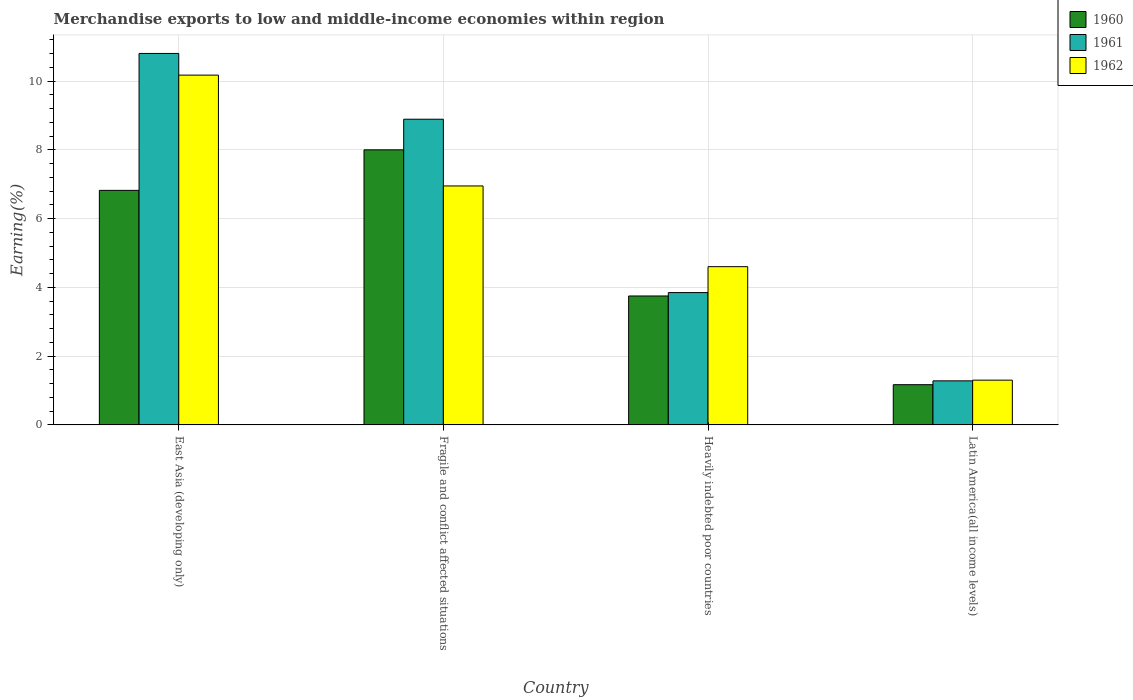How many different coloured bars are there?
Give a very brief answer. 3. How many groups of bars are there?
Provide a short and direct response. 4. How many bars are there on the 4th tick from the left?
Keep it short and to the point. 3. How many bars are there on the 2nd tick from the right?
Ensure brevity in your answer.  3. What is the label of the 4th group of bars from the left?
Offer a terse response. Latin America(all income levels). What is the percentage of amount earned from merchandise exports in 1962 in Fragile and conflict affected situations?
Provide a succinct answer. 6.95. Across all countries, what is the maximum percentage of amount earned from merchandise exports in 1962?
Offer a terse response. 10.17. Across all countries, what is the minimum percentage of amount earned from merchandise exports in 1961?
Provide a succinct answer. 1.28. In which country was the percentage of amount earned from merchandise exports in 1960 maximum?
Give a very brief answer. Fragile and conflict affected situations. In which country was the percentage of amount earned from merchandise exports in 1960 minimum?
Offer a very short reply. Latin America(all income levels). What is the total percentage of amount earned from merchandise exports in 1960 in the graph?
Give a very brief answer. 19.74. What is the difference between the percentage of amount earned from merchandise exports in 1961 in Fragile and conflict affected situations and that in Latin America(all income levels)?
Your answer should be very brief. 7.61. What is the difference between the percentage of amount earned from merchandise exports in 1961 in Latin America(all income levels) and the percentage of amount earned from merchandise exports in 1960 in East Asia (developing only)?
Provide a succinct answer. -5.54. What is the average percentage of amount earned from merchandise exports in 1962 per country?
Offer a very short reply. 5.76. What is the difference between the percentage of amount earned from merchandise exports of/in 1962 and percentage of amount earned from merchandise exports of/in 1961 in Heavily indebted poor countries?
Provide a short and direct response. 0.75. In how many countries, is the percentage of amount earned from merchandise exports in 1962 greater than 4.8 %?
Provide a short and direct response. 2. What is the ratio of the percentage of amount earned from merchandise exports in 1960 in Heavily indebted poor countries to that in Latin America(all income levels)?
Make the answer very short. 3.2. Is the percentage of amount earned from merchandise exports in 1962 in East Asia (developing only) less than that in Fragile and conflict affected situations?
Ensure brevity in your answer.  No. What is the difference between the highest and the second highest percentage of amount earned from merchandise exports in 1960?
Ensure brevity in your answer.  4.25. What is the difference between the highest and the lowest percentage of amount earned from merchandise exports in 1960?
Ensure brevity in your answer.  6.83. Is the sum of the percentage of amount earned from merchandise exports in 1962 in East Asia (developing only) and Fragile and conflict affected situations greater than the maximum percentage of amount earned from merchandise exports in 1961 across all countries?
Your answer should be compact. Yes. What does the 2nd bar from the left in East Asia (developing only) represents?
Your answer should be very brief. 1961. What does the 2nd bar from the right in Latin America(all income levels) represents?
Your response must be concise. 1961. Is it the case that in every country, the sum of the percentage of amount earned from merchandise exports in 1962 and percentage of amount earned from merchandise exports in 1960 is greater than the percentage of amount earned from merchandise exports in 1961?
Your response must be concise. Yes. Are all the bars in the graph horizontal?
Your response must be concise. No. How many countries are there in the graph?
Provide a succinct answer. 4. Are the values on the major ticks of Y-axis written in scientific E-notation?
Provide a succinct answer. No. Where does the legend appear in the graph?
Offer a terse response. Top right. How are the legend labels stacked?
Offer a very short reply. Vertical. What is the title of the graph?
Your response must be concise. Merchandise exports to low and middle-income economies within region. Does "2014" appear as one of the legend labels in the graph?
Your answer should be compact. No. What is the label or title of the X-axis?
Your answer should be compact. Country. What is the label or title of the Y-axis?
Ensure brevity in your answer.  Earning(%). What is the Earning(%) of 1960 in East Asia (developing only)?
Provide a succinct answer. 6.82. What is the Earning(%) in 1961 in East Asia (developing only)?
Your response must be concise. 10.8. What is the Earning(%) of 1962 in East Asia (developing only)?
Your answer should be compact. 10.17. What is the Earning(%) of 1960 in Fragile and conflict affected situations?
Keep it short and to the point. 8. What is the Earning(%) in 1961 in Fragile and conflict affected situations?
Your answer should be compact. 8.89. What is the Earning(%) in 1962 in Fragile and conflict affected situations?
Your answer should be compact. 6.95. What is the Earning(%) in 1960 in Heavily indebted poor countries?
Keep it short and to the point. 3.75. What is the Earning(%) of 1961 in Heavily indebted poor countries?
Give a very brief answer. 3.85. What is the Earning(%) of 1962 in Heavily indebted poor countries?
Your answer should be compact. 4.6. What is the Earning(%) in 1960 in Latin America(all income levels)?
Your answer should be compact. 1.17. What is the Earning(%) in 1961 in Latin America(all income levels)?
Provide a short and direct response. 1.28. What is the Earning(%) of 1962 in Latin America(all income levels)?
Ensure brevity in your answer.  1.3. Across all countries, what is the maximum Earning(%) in 1960?
Your response must be concise. 8. Across all countries, what is the maximum Earning(%) of 1961?
Provide a short and direct response. 10.8. Across all countries, what is the maximum Earning(%) of 1962?
Provide a short and direct response. 10.17. Across all countries, what is the minimum Earning(%) in 1960?
Your answer should be compact. 1.17. Across all countries, what is the minimum Earning(%) in 1961?
Provide a succinct answer. 1.28. Across all countries, what is the minimum Earning(%) of 1962?
Provide a short and direct response. 1.3. What is the total Earning(%) of 1960 in the graph?
Your answer should be compact. 19.74. What is the total Earning(%) of 1961 in the graph?
Keep it short and to the point. 24.83. What is the total Earning(%) of 1962 in the graph?
Your answer should be compact. 23.03. What is the difference between the Earning(%) of 1960 in East Asia (developing only) and that in Fragile and conflict affected situations?
Offer a very short reply. -1.18. What is the difference between the Earning(%) in 1961 in East Asia (developing only) and that in Fragile and conflict affected situations?
Make the answer very short. 1.91. What is the difference between the Earning(%) of 1962 in East Asia (developing only) and that in Fragile and conflict affected situations?
Give a very brief answer. 3.22. What is the difference between the Earning(%) in 1960 in East Asia (developing only) and that in Heavily indebted poor countries?
Your answer should be compact. 3.07. What is the difference between the Earning(%) in 1961 in East Asia (developing only) and that in Heavily indebted poor countries?
Ensure brevity in your answer.  6.96. What is the difference between the Earning(%) in 1962 in East Asia (developing only) and that in Heavily indebted poor countries?
Keep it short and to the point. 5.57. What is the difference between the Earning(%) in 1960 in East Asia (developing only) and that in Latin America(all income levels)?
Your answer should be very brief. 5.65. What is the difference between the Earning(%) of 1961 in East Asia (developing only) and that in Latin America(all income levels)?
Your answer should be compact. 9.52. What is the difference between the Earning(%) in 1962 in East Asia (developing only) and that in Latin America(all income levels)?
Offer a terse response. 8.87. What is the difference between the Earning(%) of 1960 in Fragile and conflict affected situations and that in Heavily indebted poor countries?
Provide a succinct answer. 4.25. What is the difference between the Earning(%) in 1961 in Fragile and conflict affected situations and that in Heavily indebted poor countries?
Ensure brevity in your answer.  5.04. What is the difference between the Earning(%) in 1962 in Fragile and conflict affected situations and that in Heavily indebted poor countries?
Your response must be concise. 2.35. What is the difference between the Earning(%) of 1960 in Fragile and conflict affected situations and that in Latin America(all income levels)?
Provide a succinct answer. 6.83. What is the difference between the Earning(%) of 1961 in Fragile and conflict affected situations and that in Latin America(all income levels)?
Your answer should be compact. 7.61. What is the difference between the Earning(%) in 1962 in Fragile and conflict affected situations and that in Latin America(all income levels)?
Give a very brief answer. 5.65. What is the difference between the Earning(%) of 1960 in Heavily indebted poor countries and that in Latin America(all income levels)?
Provide a short and direct response. 2.58. What is the difference between the Earning(%) in 1961 in Heavily indebted poor countries and that in Latin America(all income levels)?
Give a very brief answer. 2.57. What is the difference between the Earning(%) in 1962 in Heavily indebted poor countries and that in Latin America(all income levels)?
Your answer should be very brief. 3.3. What is the difference between the Earning(%) of 1960 in East Asia (developing only) and the Earning(%) of 1961 in Fragile and conflict affected situations?
Your answer should be compact. -2.07. What is the difference between the Earning(%) of 1960 in East Asia (developing only) and the Earning(%) of 1962 in Fragile and conflict affected situations?
Give a very brief answer. -0.13. What is the difference between the Earning(%) in 1961 in East Asia (developing only) and the Earning(%) in 1962 in Fragile and conflict affected situations?
Your response must be concise. 3.85. What is the difference between the Earning(%) of 1960 in East Asia (developing only) and the Earning(%) of 1961 in Heavily indebted poor countries?
Provide a succinct answer. 2.97. What is the difference between the Earning(%) of 1960 in East Asia (developing only) and the Earning(%) of 1962 in Heavily indebted poor countries?
Your response must be concise. 2.22. What is the difference between the Earning(%) in 1961 in East Asia (developing only) and the Earning(%) in 1962 in Heavily indebted poor countries?
Make the answer very short. 6.2. What is the difference between the Earning(%) in 1960 in East Asia (developing only) and the Earning(%) in 1961 in Latin America(all income levels)?
Ensure brevity in your answer.  5.54. What is the difference between the Earning(%) in 1960 in East Asia (developing only) and the Earning(%) in 1962 in Latin America(all income levels)?
Offer a terse response. 5.52. What is the difference between the Earning(%) in 1961 in East Asia (developing only) and the Earning(%) in 1962 in Latin America(all income levels)?
Provide a short and direct response. 9.5. What is the difference between the Earning(%) in 1960 in Fragile and conflict affected situations and the Earning(%) in 1961 in Heavily indebted poor countries?
Keep it short and to the point. 4.15. What is the difference between the Earning(%) in 1960 in Fragile and conflict affected situations and the Earning(%) in 1962 in Heavily indebted poor countries?
Ensure brevity in your answer.  3.4. What is the difference between the Earning(%) of 1961 in Fragile and conflict affected situations and the Earning(%) of 1962 in Heavily indebted poor countries?
Give a very brief answer. 4.29. What is the difference between the Earning(%) in 1960 in Fragile and conflict affected situations and the Earning(%) in 1961 in Latin America(all income levels)?
Your answer should be very brief. 6.72. What is the difference between the Earning(%) in 1960 in Fragile and conflict affected situations and the Earning(%) in 1962 in Latin America(all income levels)?
Offer a very short reply. 6.7. What is the difference between the Earning(%) of 1961 in Fragile and conflict affected situations and the Earning(%) of 1962 in Latin America(all income levels)?
Your response must be concise. 7.59. What is the difference between the Earning(%) of 1960 in Heavily indebted poor countries and the Earning(%) of 1961 in Latin America(all income levels)?
Ensure brevity in your answer.  2.47. What is the difference between the Earning(%) of 1960 in Heavily indebted poor countries and the Earning(%) of 1962 in Latin America(all income levels)?
Your response must be concise. 2.45. What is the difference between the Earning(%) in 1961 in Heavily indebted poor countries and the Earning(%) in 1962 in Latin America(all income levels)?
Make the answer very short. 2.55. What is the average Earning(%) of 1960 per country?
Keep it short and to the point. 4.94. What is the average Earning(%) in 1961 per country?
Provide a short and direct response. 6.21. What is the average Earning(%) in 1962 per country?
Offer a very short reply. 5.76. What is the difference between the Earning(%) in 1960 and Earning(%) in 1961 in East Asia (developing only)?
Offer a terse response. -3.98. What is the difference between the Earning(%) in 1960 and Earning(%) in 1962 in East Asia (developing only)?
Provide a succinct answer. -3.35. What is the difference between the Earning(%) in 1961 and Earning(%) in 1962 in East Asia (developing only)?
Offer a terse response. 0.63. What is the difference between the Earning(%) in 1960 and Earning(%) in 1961 in Fragile and conflict affected situations?
Provide a succinct answer. -0.89. What is the difference between the Earning(%) in 1960 and Earning(%) in 1962 in Fragile and conflict affected situations?
Ensure brevity in your answer.  1.05. What is the difference between the Earning(%) in 1961 and Earning(%) in 1962 in Fragile and conflict affected situations?
Make the answer very short. 1.94. What is the difference between the Earning(%) of 1960 and Earning(%) of 1961 in Heavily indebted poor countries?
Provide a succinct answer. -0.1. What is the difference between the Earning(%) of 1960 and Earning(%) of 1962 in Heavily indebted poor countries?
Offer a very short reply. -0.85. What is the difference between the Earning(%) in 1961 and Earning(%) in 1962 in Heavily indebted poor countries?
Provide a succinct answer. -0.75. What is the difference between the Earning(%) of 1960 and Earning(%) of 1961 in Latin America(all income levels)?
Give a very brief answer. -0.11. What is the difference between the Earning(%) in 1960 and Earning(%) in 1962 in Latin America(all income levels)?
Offer a very short reply. -0.13. What is the difference between the Earning(%) in 1961 and Earning(%) in 1962 in Latin America(all income levels)?
Offer a very short reply. -0.02. What is the ratio of the Earning(%) in 1960 in East Asia (developing only) to that in Fragile and conflict affected situations?
Make the answer very short. 0.85. What is the ratio of the Earning(%) of 1961 in East Asia (developing only) to that in Fragile and conflict affected situations?
Keep it short and to the point. 1.22. What is the ratio of the Earning(%) of 1962 in East Asia (developing only) to that in Fragile and conflict affected situations?
Give a very brief answer. 1.46. What is the ratio of the Earning(%) of 1960 in East Asia (developing only) to that in Heavily indebted poor countries?
Offer a very short reply. 1.82. What is the ratio of the Earning(%) in 1961 in East Asia (developing only) to that in Heavily indebted poor countries?
Offer a terse response. 2.81. What is the ratio of the Earning(%) in 1962 in East Asia (developing only) to that in Heavily indebted poor countries?
Offer a terse response. 2.21. What is the ratio of the Earning(%) in 1960 in East Asia (developing only) to that in Latin America(all income levels)?
Make the answer very short. 5.83. What is the ratio of the Earning(%) of 1961 in East Asia (developing only) to that in Latin America(all income levels)?
Your answer should be compact. 8.43. What is the ratio of the Earning(%) in 1962 in East Asia (developing only) to that in Latin America(all income levels)?
Provide a short and direct response. 7.81. What is the ratio of the Earning(%) of 1960 in Fragile and conflict affected situations to that in Heavily indebted poor countries?
Provide a short and direct response. 2.13. What is the ratio of the Earning(%) in 1961 in Fragile and conflict affected situations to that in Heavily indebted poor countries?
Provide a short and direct response. 2.31. What is the ratio of the Earning(%) in 1962 in Fragile and conflict affected situations to that in Heavily indebted poor countries?
Offer a very short reply. 1.51. What is the ratio of the Earning(%) in 1960 in Fragile and conflict affected situations to that in Latin America(all income levels)?
Offer a terse response. 6.84. What is the ratio of the Earning(%) in 1961 in Fragile and conflict affected situations to that in Latin America(all income levels)?
Provide a succinct answer. 6.94. What is the ratio of the Earning(%) of 1962 in Fragile and conflict affected situations to that in Latin America(all income levels)?
Make the answer very short. 5.34. What is the ratio of the Earning(%) in 1960 in Heavily indebted poor countries to that in Latin America(all income levels)?
Keep it short and to the point. 3.2. What is the ratio of the Earning(%) in 1961 in Heavily indebted poor countries to that in Latin America(all income levels)?
Make the answer very short. 3. What is the ratio of the Earning(%) of 1962 in Heavily indebted poor countries to that in Latin America(all income levels)?
Make the answer very short. 3.54. What is the difference between the highest and the second highest Earning(%) in 1960?
Your response must be concise. 1.18. What is the difference between the highest and the second highest Earning(%) of 1961?
Ensure brevity in your answer.  1.91. What is the difference between the highest and the second highest Earning(%) in 1962?
Keep it short and to the point. 3.22. What is the difference between the highest and the lowest Earning(%) in 1960?
Ensure brevity in your answer.  6.83. What is the difference between the highest and the lowest Earning(%) in 1961?
Give a very brief answer. 9.52. What is the difference between the highest and the lowest Earning(%) of 1962?
Ensure brevity in your answer.  8.87. 